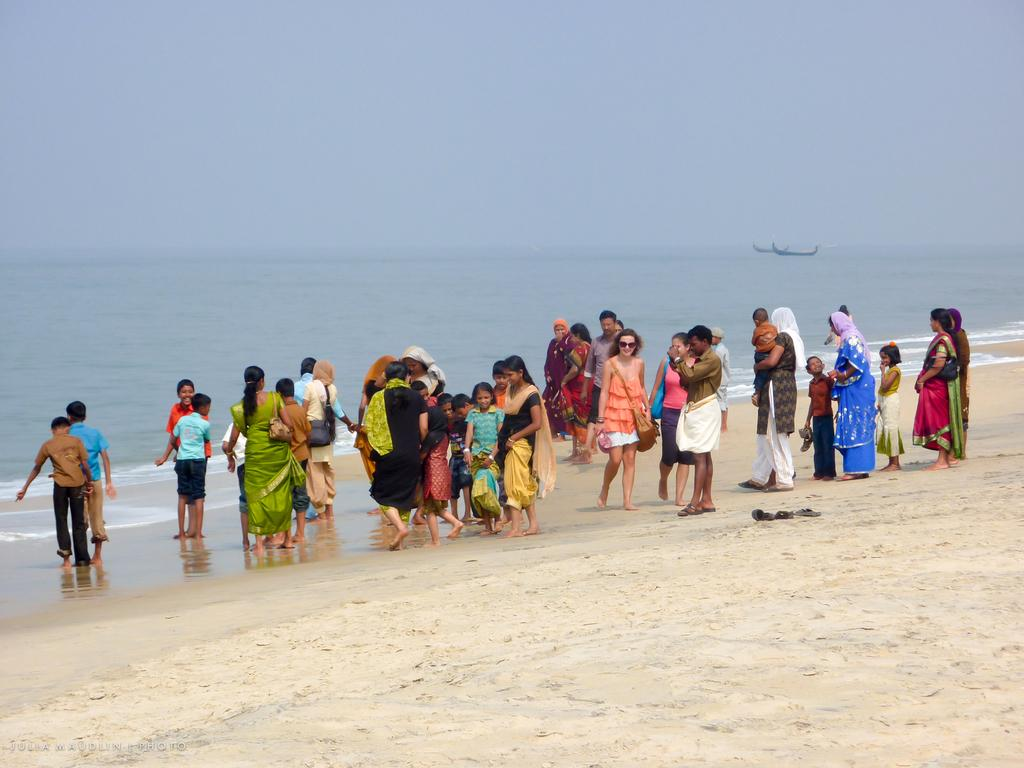Who is present in the image? There are people in the image. Where are the people located? The people are standing on a beach. Can you describe the demographics of the people in the image? There are men, women, and children in the image. What can be seen in the background of the image? There is an ocean and the sky visible in the background of the image. What type of lawyer is saying good-bye to the basket on the beach in the image? There is no lawyer, good-bye, or basket present in the image. 